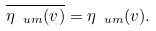<formula> <loc_0><loc_0><loc_500><loc_500>\overline { \eta _ { \ u m } ( v ) } = \eta _ { \ u m } ( v ) .</formula> 